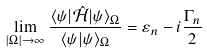<formula> <loc_0><loc_0><loc_500><loc_500>\lim _ { | \Omega | \to \infty } \frac { \langle \psi | \hat { \mathcal { H } } | \psi \rangle _ { \Omega } } { \langle \psi | \psi \rangle _ { \Omega } } = \varepsilon _ { n } - i \frac { \Gamma _ { n } } { 2 }</formula> 